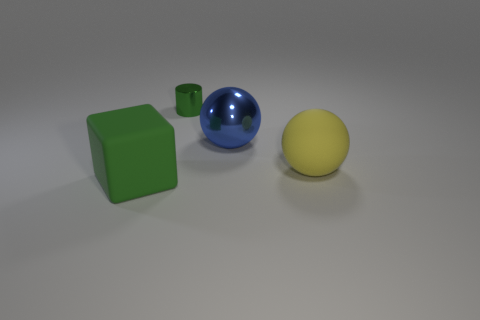Add 2 green metallic cylinders. How many objects exist? 6 Subtract all cylinders. How many objects are left? 3 Subtract all metallic cylinders. Subtract all large yellow matte things. How many objects are left? 2 Add 2 green shiny objects. How many green shiny objects are left? 3 Add 2 large cyan shiny cubes. How many large cyan shiny cubes exist? 2 Subtract 0 gray cylinders. How many objects are left? 4 